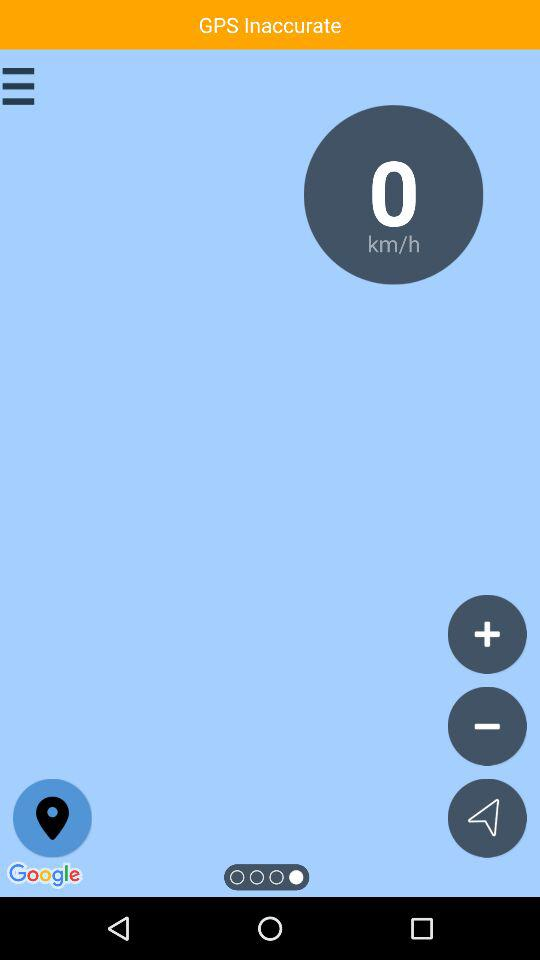How much is the speed? The speed is 0 km/h. 